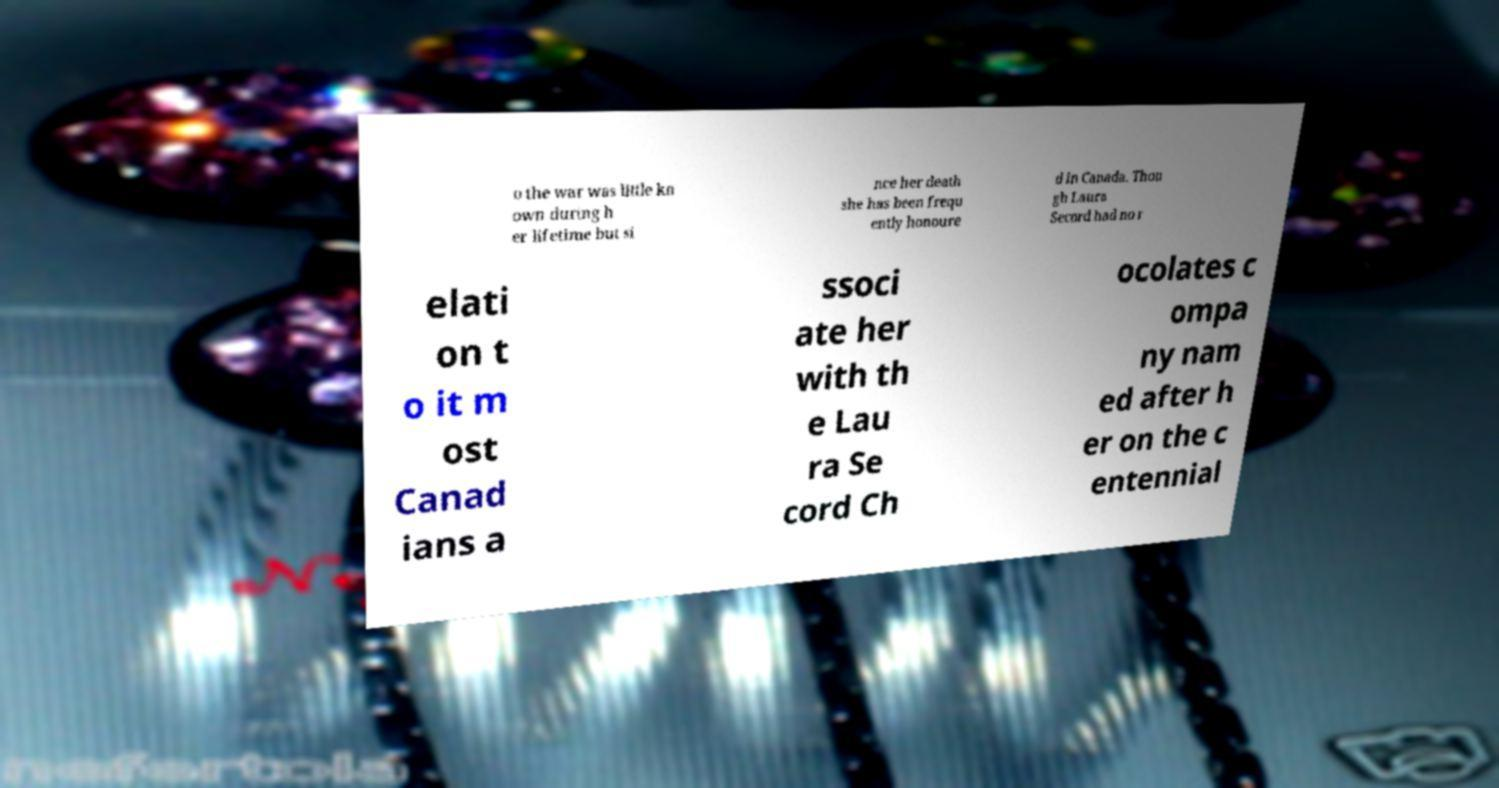Could you extract and type out the text from this image? o the war was little kn own during h er lifetime but si nce her death she has been frequ ently honoure d in Canada. Thou gh Laura Secord had no r elati on t o it m ost Canad ians a ssoci ate her with th e Lau ra Se cord Ch ocolates c ompa ny nam ed after h er on the c entennial 